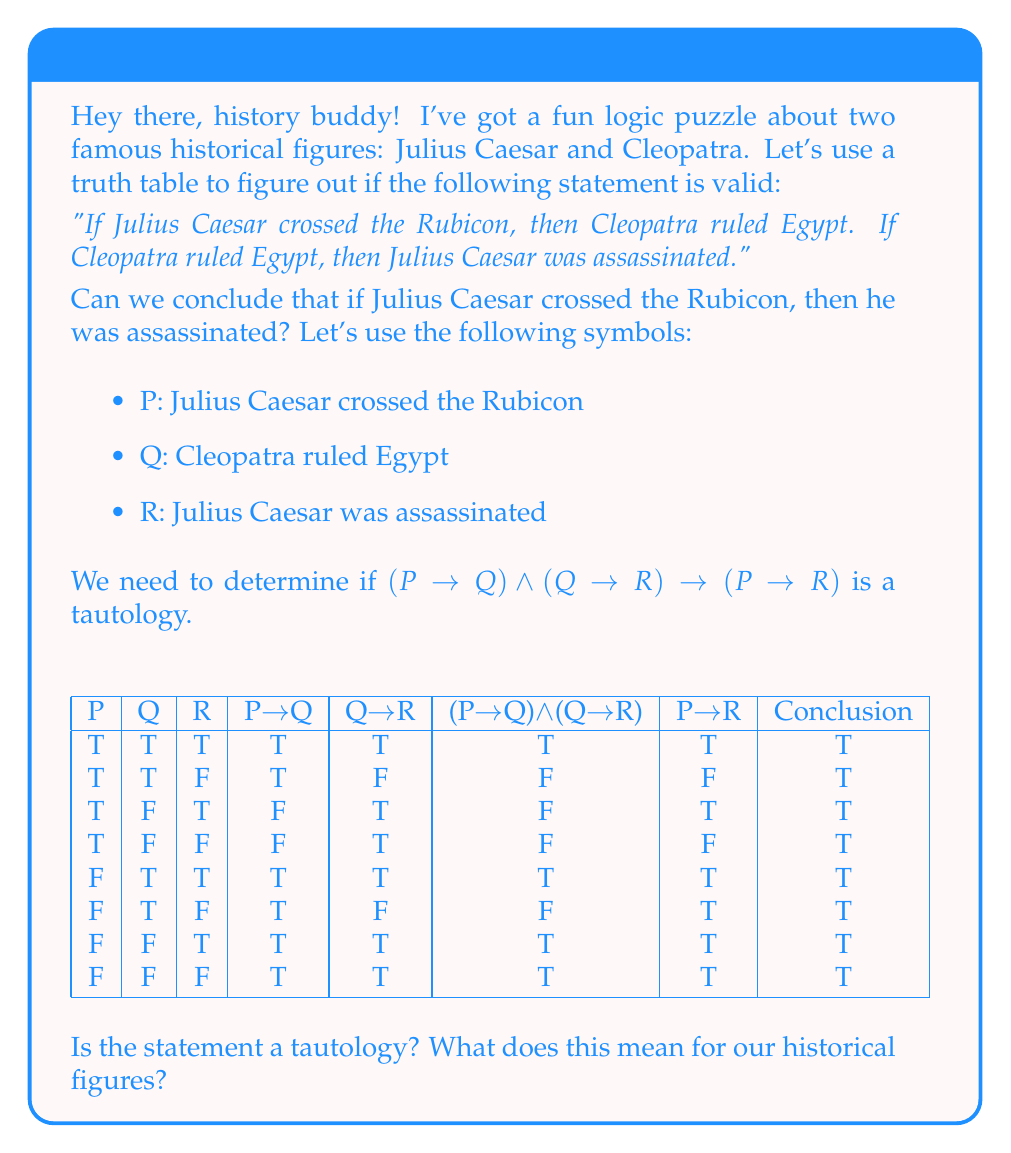Show me your answer to this math problem. Let's analyze this step-by-step:

1) First, we need to understand what a tautology is. A tautology is a statement that is always true, regardless of the truth values of its components.

2) We've constructed a truth table for the statement $(P \rightarrow Q) \land (Q \rightarrow R) \rightarrow (P \rightarrow R)$.

3) Let's break down each column:
   - Columns P, Q, and R show all possible combinations of truth values for our basic statements.
   - Column "P→Q" is true except when P is true and Q is false.
   - Column "Q→R" is true except when Q is true and R is false.
   - Column "(P→Q)∧(Q→R)" is the conjunction of the previous two columns.
   - Column "P→R" is true except when P is true and R is false.
   - The "Conclusion" column shows whether the entire statement is true for each row.

4) We can see that the "Conclusion" column is always true (T), regardless of the truth values of P, Q, and R.

5) This means that the statement $(P \rightarrow Q) \land (Q \rightarrow R) \rightarrow (P \rightarrow R)$ is indeed a tautology.

6) In terms of our historical figures, this means that if we accept the premises "If Julius Caesar crossed the Rubicon, then Cleopatra ruled Egypt" and "If Cleopatra ruled Egypt, then Julius Caesar was assassinated", we must logically conclude that "If Julius Caesar crossed the Rubicon, then he was assassinated".

7) However, it's important to note that this logical conclusion doesn't necessarily reflect historical accuracy. It's just a demonstration of how logical implication works.
Answer: Yes, it's a tautology. Logically, if Caesar crossed the Rubicon, he was assassinated, given the premises. 